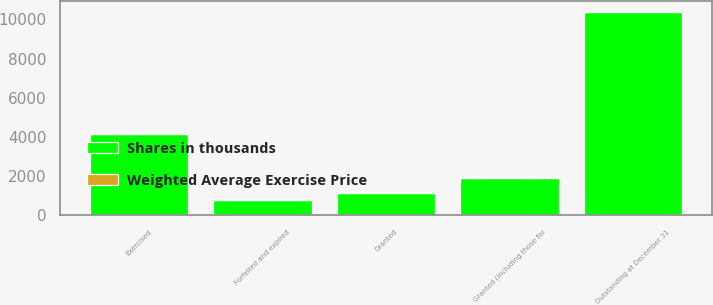Convert chart to OTSL. <chart><loc_0><loc_0><loc_500><loc_500><stacked_bar_chart><ecel><fcel>Outstanding at December 31<fcel>Granted (including those for<fcel>Exercised<fcel>Forfeited and expired<fcel>Granted<nl><fcel>Shares in thousands<fcel>10380<fcel>1932<fcel>4153<fcel>808<fcel>1162<nl><fcel>Weighted Average Exercise Price<fcel>18.76<fcel>26.96<fcel>5.18<fcel>12.19<fcel>28.2<nl></chart> 